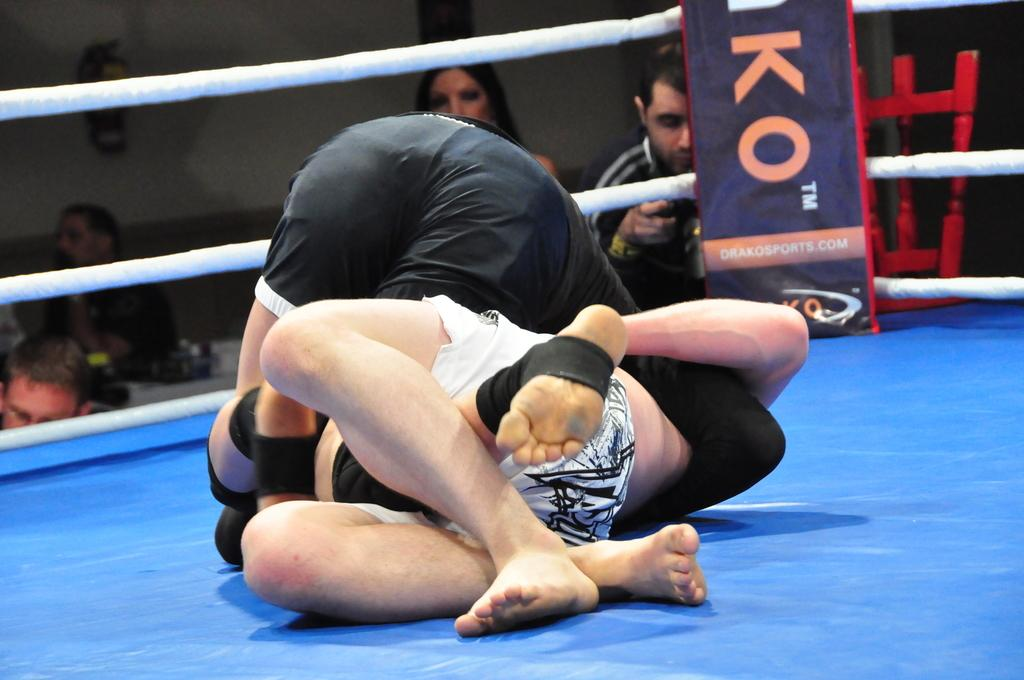<image>
Offer a succinct explanation of the picture presented. Two MMA fighters are on the floor of a ring that is sponsored by Drako Sports. 